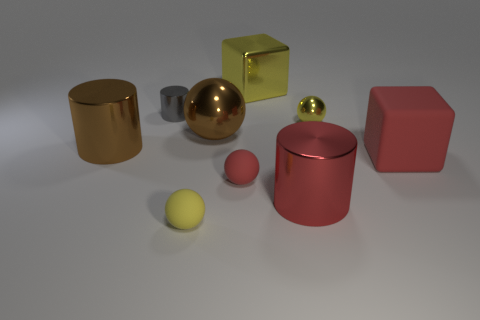Subtract all cubes. How many objects are left? 7 Add 6 red shiny cylinders. How many red shiny cylinders are left? 7 Add 3 yellow balls. How many yellow balls exist? 5 Subtract 0 green cubes. How many objects are left? 9 Subtract all small green matte cylinders. Subtract all small spheres. How many objects are left? 6 